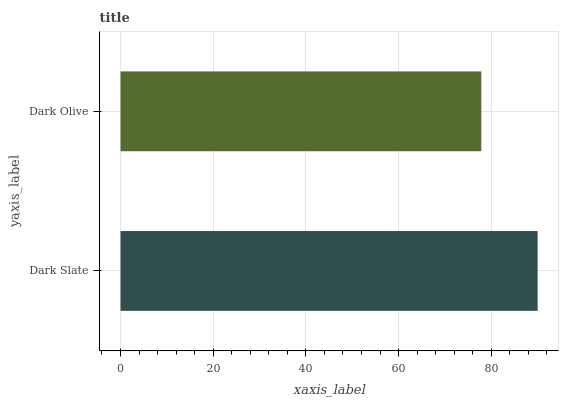Is Dark Olive the minimum?
Answer yes or no. Yes. Is Dark Slate the maximum?
Answer yes or no. Yes. Is Dark Olive the maximum?
Answer yes or no. No. Is Dark Slate greater than Dark Olive?
Answer yes or no. Yes. Is Dark Olive less than Dark Slate?
Answer yes or no. Yes. Is Dark Olive greater than Dark Slate?
Answer yes or no. No. Is Dark Slate less than Dark Olive?
Answer yes or no. No. Is Dark Slate the high median?
Answer yes or no. Yes. Is Dark Olive the low median?
Answer yes or no. Yes. Is Dark Olive the high median?
Answer yes or no. No. Is Dark Slate the low median?
Answer yes or no. No. 